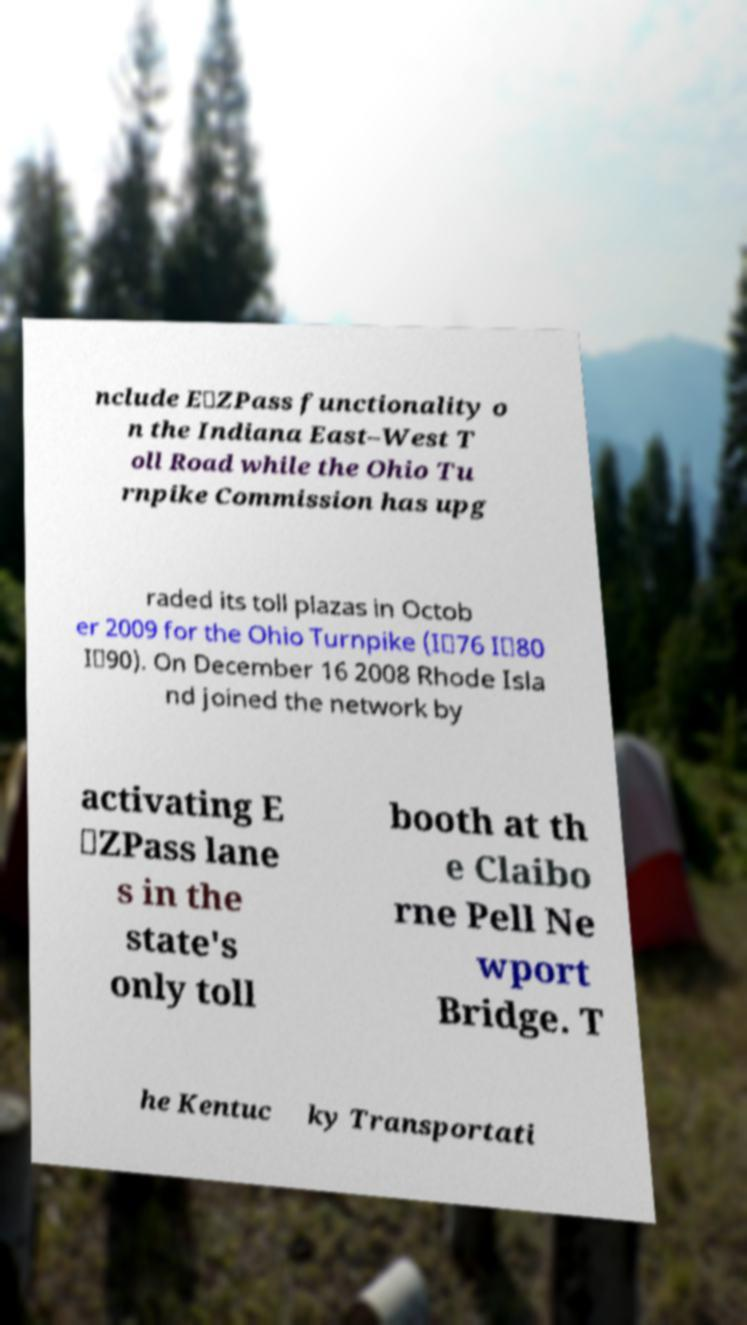There's text embedded in this image that I need extracted. Can you transcribe it verbatim? nclude E‑ZPass functionality o n the Indiana East–West T oll Road while the Ohio Tu rnpike Commission has upg raded its toll plazas in Octob er 2009 for the Ohio Turnpike (I‑76 I‑80 I‑90). On December 16 2008 Rhode Isla nd joined the network by activating E ‑ZPass lane s in the state's only toll booth at th e Claibo rne Pell Ne wport Bridge. T he Kentuc ky Transportati 